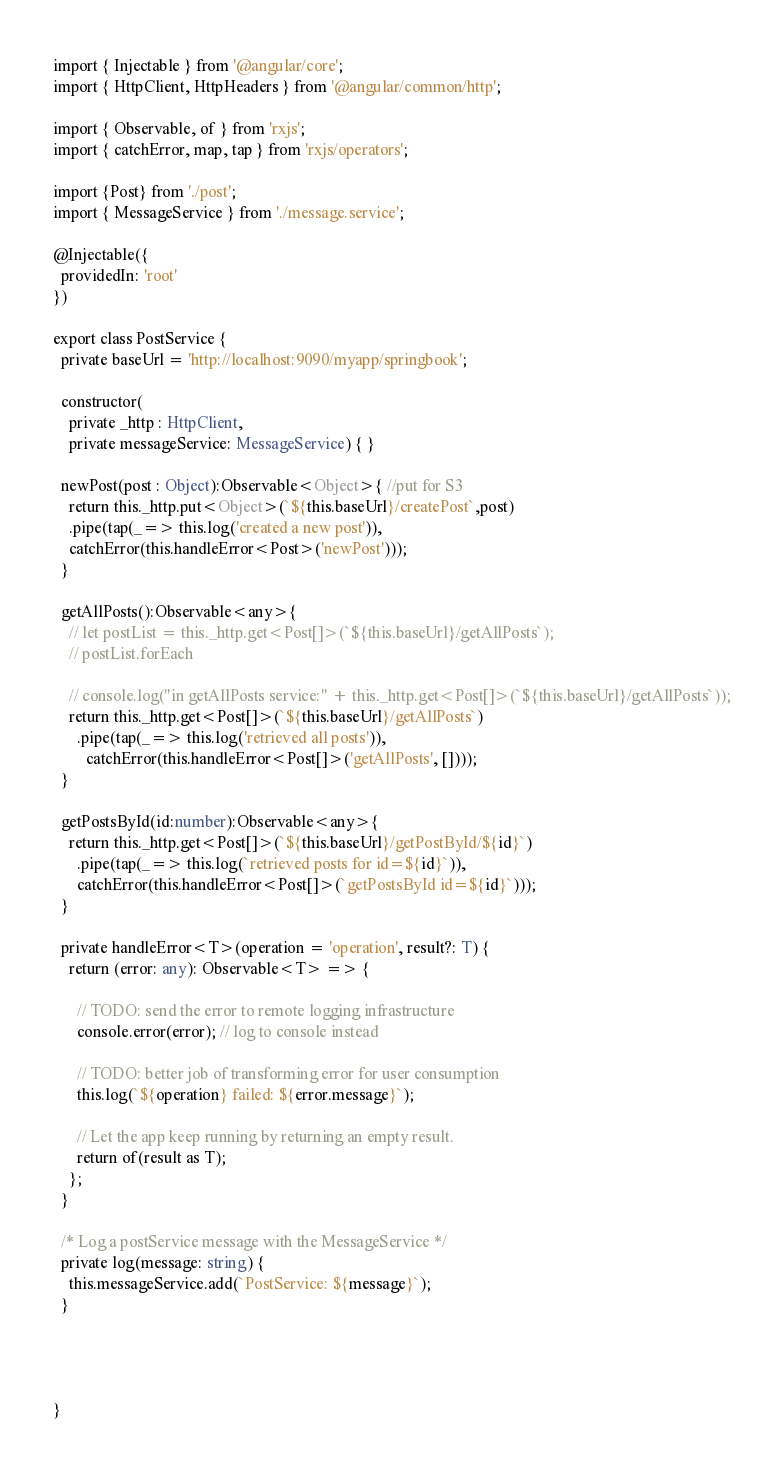Convert code to text. <code><loc_0><loc_0><loc_500><loc_500><_TypeScript_>import { Injectable } from '@angular/core';
import { HttpClient, HttpHeaders } from '@angular/common/http';

import { Observable, of } from 'rxjs';
import { catchError, map, tap } from 'rxjs/operators';

import {Post} from './post';
import { MessageService } from './message.service';

@Injectable({
  providedIn: 'root'
})

export class PostService {
  private baseUrl = 'http://localhost:9090/myapp/springbook';

  constructor(
    private _http : HttpClient,
    private messageService: MessageService) { }

  newPost(post : Object):Observable<Object>{ //put for S3
    return this._http.put<Object>(`${this.baseUrl}/createPost`,post)
    .pipe(tap(_=> this.log('created a new post')),
    catchError(this.handleError<Post>('newPost')));
  }

  getAllPosts():Observable<any>{
    // let postList = this._http.get<Post[]>(`${this.baseUrl}/getAllPosts`);
    // postList.forEach

    // console.log("in getAllPosts service:" + this._http.get<Post[]>(`${this.baseUrl}/getAllPosts`));
    return this._http.get<Post[]>(`${this.baseUrl}/getAllPosts`)
      .pipe(tap(_=> this.log('retrieved all posts')),
        catchError(this.handleError<Post[]>('getAllPosts', [])));
  }

  getPostsById(id:number):Observable<any>{
    return this._http.get<Post[]>(`${this.baseUrl}/getPostById/${id}`)
      .pipe(tap(_=> this.log(`retrieved posts for id=${id}`)),
      catchError(this.handleError<Post[]>(`getPostsById id=${id}`)));
  }

  private handleError<T>(operation = 'operation', result?: T) {
    return (error: any): Observable<T> => {

      // TODO: send the error to remote logging infrastructure
      console.error(error); // log to console instead

      // TODO: better job of transforming error for user consumption
      this.log(`${operation} failed: ${error.message}`);

      // Let the app keep running by returning an empty result.
      return of(result as T);
    };
  }

  /* Log a postService message with the MessageService */
  private log(message: string) {
    this.messageService.add(`PostService: ${message}`);
  }




}
</code> 